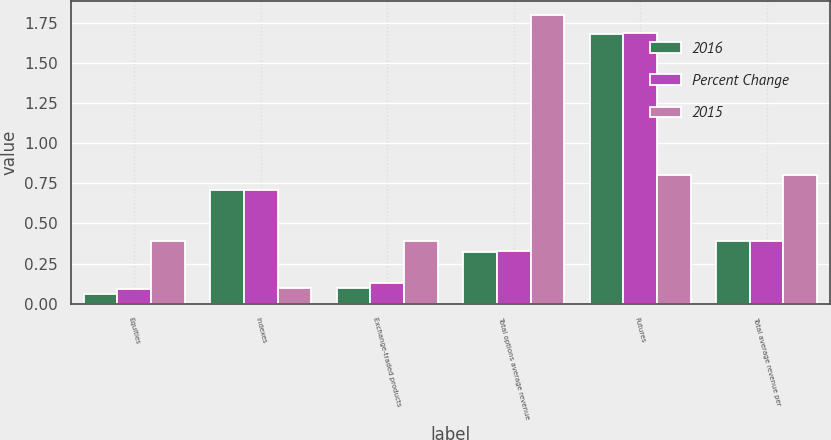Convert chart. <chart><loc_0><loc_0><loc_500><loc_500><stacked_bar_chart><ecel><fcel>Equities<fcel>Indexes<fcel>Exchange-traded products<fcel>Total options average revenue<fcel>Futures<fcel>Total average revenue per<nl><fcel>2016<fcel>0.06<fcel>0.71<fcel>0.1<fcel>0.32<fcel>1.68<fcel>0.39<nl><fcel>Percent Change<fcel>0.09<fcel>0.71<fcel>0.13<fcel>0.33<fcel>1.69<fcel>0.39<nl><fcel>2015<fcel>0.39<fcel>0.1<fcel>0.39<fcel>1.8<fcel>0.8<fcel>0.8<nl></chart> 